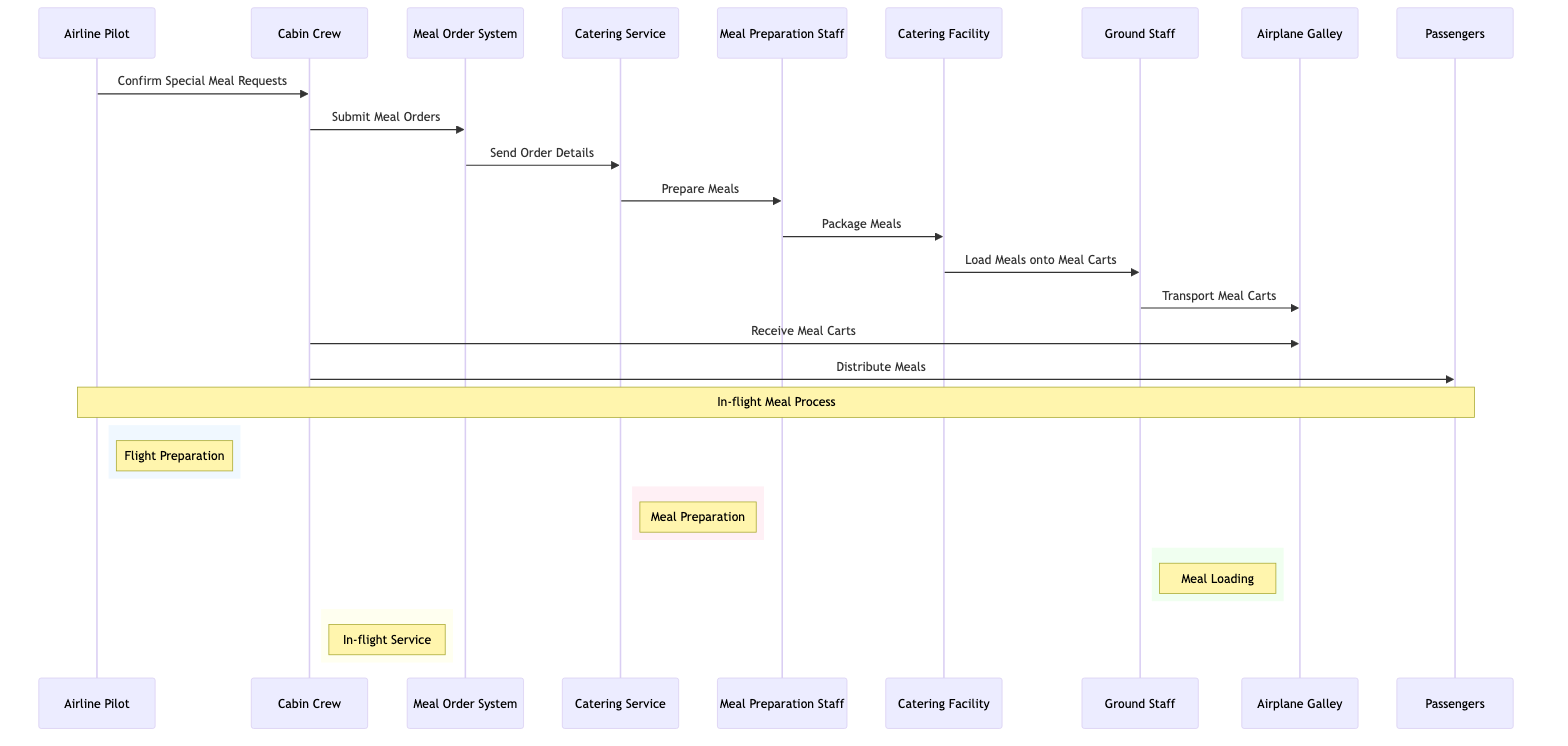What's the total number of actors in the diagram? The diagram lists six actors: Airline Pilot, Cabin Crew, Ground Staff, Catering Service, Meal Preparation Staff, and Passengers. Counting these gives a total of 6 actors.
Answer: 6 Which actor submits meal orders? From the diagram, it shows that the Cabin Crew is the actor responsible for submitting meal orders to the Meal Order System.
Answer: Cabin Crew What action follows the "Prepare Meals" action? In the sequence, after the "Prepare Meals" action performed by Meal Preparation Staff, the next action is "Package Meals." This indicates the sequence in meal preparation activities.
Answer: Package Meals Who receives the meal carts in the airplane? According to the diagram, the Cabin Crew is responsible for receiving meal carts after they have been transported to the Airplane Galley.
Answer: Cabin Crew How many steps are there from ordering to meal distribution? The sequence lists eight distinct actions from the initial meal order submission to the final meal distribution to passengers, indicating a multi-step process of the in-flight meal service.
Answer: 8 What system sends order details to the catering service? The Meal Order System is the system responsible for sending order details to the Catering Service, facilitating the meal preparation process based on the submitted orders.
Answer: Meal Order System What color represents the meal preparation phase? The meal preparation phase, delimited in the diagram by a rectangle, is represented in the color that corresponds to the note labeled with "Meal Preparation." The RGB color for this phase is indicated as rgb(255, 240, 245).
Answer: rgb(255, 240, 245) Which phase occurs after meal loading? Following the meal loading phase, which involves the Ground Staff transporting the meal carts, the next phase is "In-flight Service," where the Cabin Crew distributes meals to the passengers.
Answer: In-flight Service 